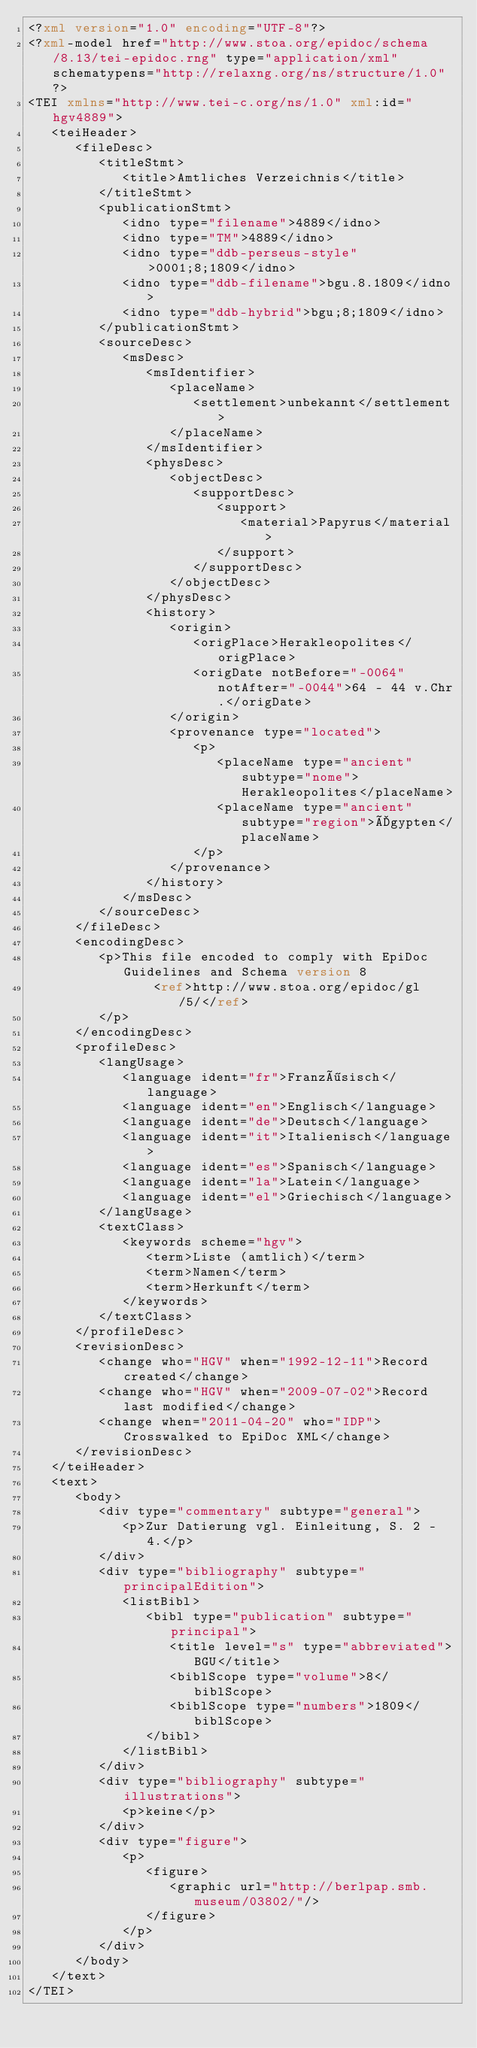Convert code to text. <code><loc_0><loc_0><loc_500><loc_500><_XML_><?xml version="1.0" encoding="UTF-8"?>
<?xml-model href="http://www.stoa.org/epidoc/schema/8.13/tei-epidoc.rng" type="application/xml" schematypens="http://relaxng.org/ns/structure/1.0"?>
<TEI xmlns="http://www.tei-c.org/ns/1.0" xml:id="hgv4889">
   <teiHeader>
      <fileDesc>
         <titleStmt>
            <title>Amtliches Verzeichnis</title>
         </titleStmt>
         <publicationStmt>
            <idno type="filename">4889</idno>
            <idno type="TM">4889</idno>
            <idno type="ddb-perseus-style">0001;8;1809</idno>
            <idno type="ddb-filename">bgu.8.1809</idno>
            <idno type="ddb-hybrid">bgu;8;1809</idno>
         </publicationStmt>
         <sourceDesc>
            <msDesc>
               <msIdentifier>
                  <placeName>
                     <settlement>unbekannt</settlement>
                  </placeName>
               </msIdentifier>
               <physDesc>
                  <objectDesc>
                     <supportDesc>
                        <support>
                           <material>Papyrus</material>
                        </support>
                     </supportDesc>
                  </objectDesc>
               </physDesc>
               <history>
                  <origin>
                     <origPlace>Herakleopolites</origPlace>
                     <origDate notBefore="-0064" notAfter="-0044">64 - 44 v.Chr.</origDate>
                  </origin>
                  <provenance type="located">
                     <p>
                        <placeName type="ancient" subtype="nome">Herakleopolites</placeName>
                        <placeName type="ancient" subtype="region">Ägypten</placeName>
                     </p>
                  </provenance>
               </history>
            </msDesc>
         </sourceDesc>
      </fileDesc>
      <encodingDesc>
         <p>This file encoded to comply with EpiDoc Guidelines and Schema version 8
                <ref>http://www.stoa.org/epidoc/gl/5/</ref>
         </p>
      </encodingDesc>
      <profileDesc>
         <langUsage>
            <language ident="fr">Französisch</language>
            <language ident="en">Englisch</language>
            <language ident="de">Deutsch</language>
            <language ident="it">Italienisch</language>
            <language ident="es">Spanisch</language>
            <language ident="la">Latein</language>
            <language ident="el">Griechisch</language>
         </langUsage>
         <textClass>
            <keywords scheme="hgv">
               <term>Liste (amtlich)</term>
               <term>Namen</term>
               <term>Herkunft</term>
            </keywords>
         </textClass>
      </profileDesc>
      <revisionDesc>
         <change who="HGV" when="1992-12-11">Record created</change>
         <change who="HGV" when="2009-07-02">Record last modified</change>
         <change when="2011-04-20" who="IDP">Crosswalked to EpiDoc XML</change>
      </revisionDesc>
   </teiHeader>
   <text>
      <body>
         <div type="commentary" subtype="general">
            <p>Zur Datierung vgl. Einleitung, S. 2 - 4.</p>
         </div>
         <div type="bibliography" subtype="principalEdition">
            <listBibl>
               <bibl type="publication" subtype="principal">
                  <title level="s" type="abbreviated">BGU</title>
                  <biblScope type="volume">8</biblScope>
                  <biblScope type="numbers">1809</biblScope>
               </bibl>
            </listBibl>
         </div>
         <div type="bibliography" subtype="illustrations">
            <p>keine</p>
         </div>
         <div type="figure">
            <p>
               <figure>
                  <graphic url="http://berlpap.smb.museum/03802/"/>
               </figure>
            </p>
         </div>
      </body>
   </text>
</TEI>
</code> 